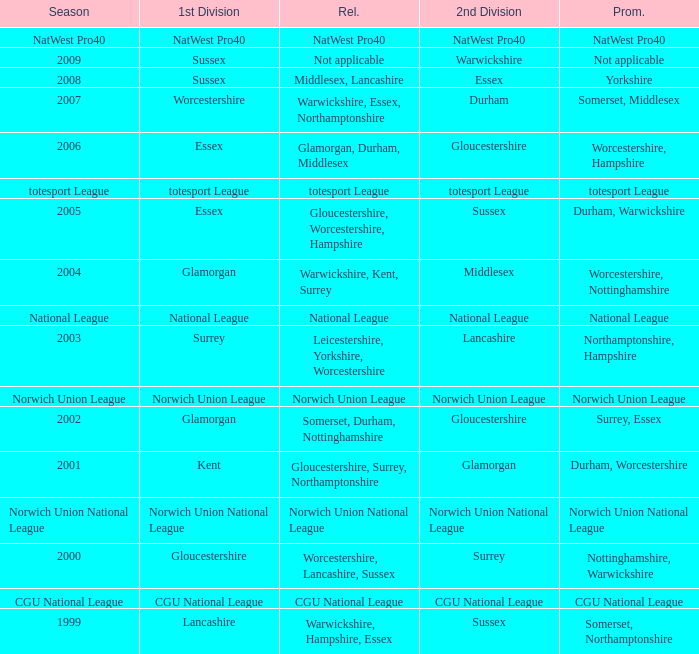What was relegated in the 2nd division of middlesex? Warwickshire, Kent, Surrey. 